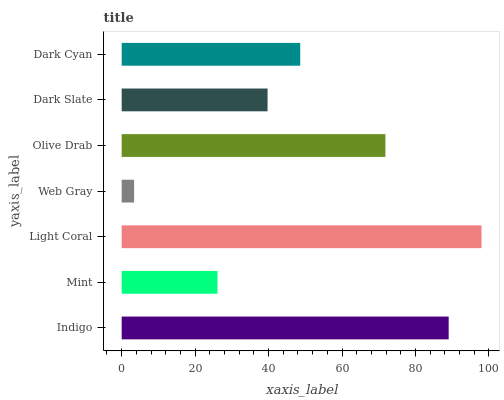Is Web Gray the minimum?
Answer yes or no. Yes. Is Light Coral the maximum?
Answer yes or no. Yes. Is Mint the minimum?
Answer yes or no. No. Is Mint the maximum?
Answer yes or no. No. Is Indigo greater than Mint?
Answer yes or no. Yes. Is Mint less than Indigo?
Answer yes or no. Yes. Is Mint greater than Indigo?
Answer yes or no. No. Is Indigo less than Mint?
Answer yes or no. No. Is Dark Cyan the high median?
Answer yes or no. Yes. Is Dark Cyan the low median?
Answer yes or no. Yes. Is Light Coral the high median?
Answer yes or no. No. Is Indigo the low median?
Answer yes or no. No. 